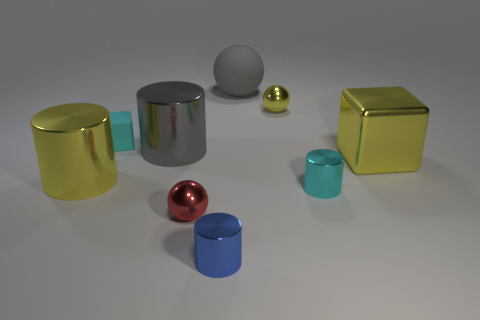What number of other objects are the same color as the shiny block?
Your answer should be compact. 2. What is the shape of the cyan metallic thing that is the same size as the red metallic object?
Give a very brief answer. Cylinder. How many tiny things are either gray things or blue rubber things?
Give a very brief answer. 0. Are there any large yellow metal objects that are to the right of the small blue cylinder in front of the cyan thing to the left of the small yellow metallic ball?
Make the answer very short. Yes. Are there any green metallic things of the same size as the cyan metal cylinder?
Provide a succinct answer. No. What is the material of the yellow sphere that is the same size as the red ball?
Provide a short and direct response. Metal. Is the size of the gray sphere the same as the cyan thing that is behind the big yellow metallic cylinder?
Your answer should be very brief. No. What number of shiny objects are big red cylinders or blue cylinders?
Keep it short and to the point. 1. How many other yellow things are the same shape as the tiny yellow thing?
Your answer should be very brief. 0. There is another object that is the same color as the large matte object; what material is it?
Provide a short and direct response. Metal. 